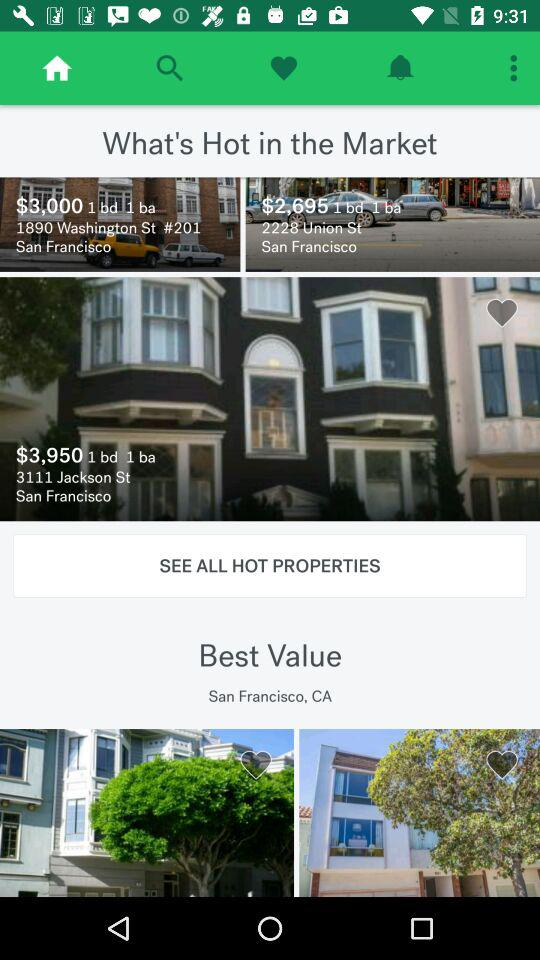What state is mentioned? The mentioned state is San Francisco, CA. 